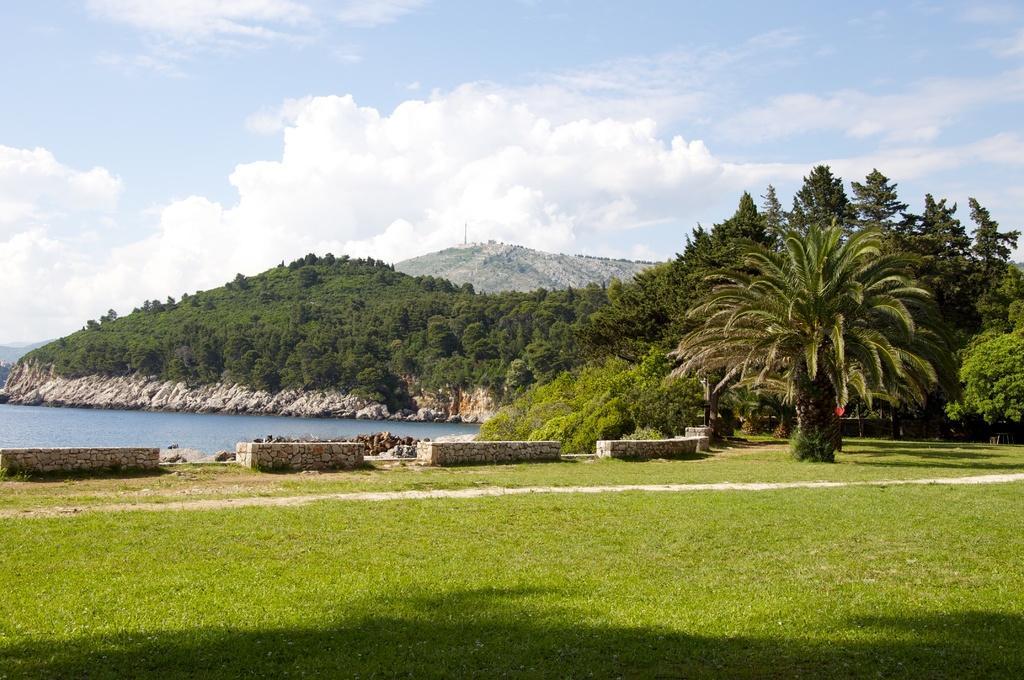Describe this image in one or two sentences. In this picture we can see grass on the ground, here we can see walls, stones, water and in the background we can see trees, mountains and sky with clouds. 